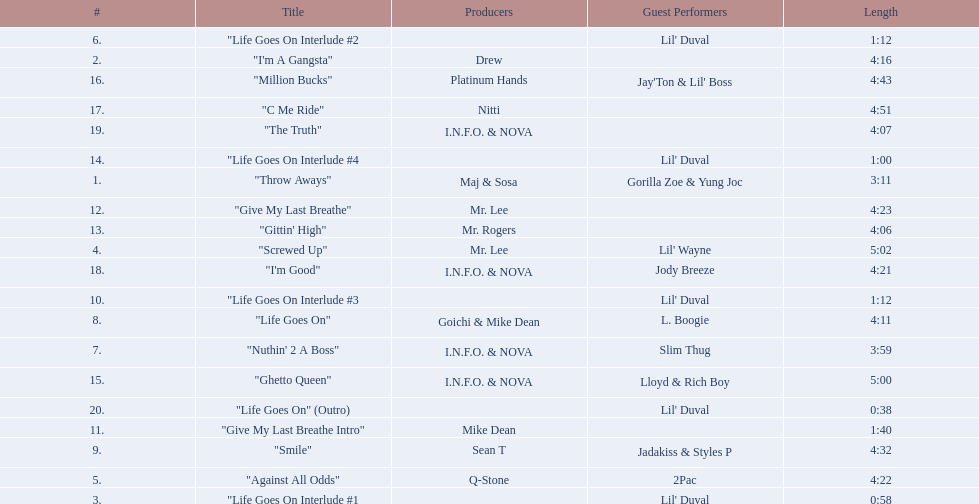How long is track number 11? 1:40. Can you parse all the data within this table? {'header': ['#', 'Title', 'Producers', 'Guest Performers', 'Length'], 'rows': [['6.', '"Life Goes On Interlude #2', '', "Lil' Duval", '1:12'], ['2.', '"I\'m A Gangsta"', 'Drew', '', '4:16'], ['16.', '"Million Bucks"', 'Platinum Hands', "Jay'Ton & Lil' Boss", '4:43'], ['17.', '"C Me Ride"', 'Nitti', '', '4:51'], ['19.', '"The Truth"', 'I.N.F.O. & NOVA', '', '4:07'], ['14.', '"Life Goes On Interlude #4', '', "Lil' Duval", '1:00'], ['1.', '"Throw Aways"', 'Maj & Sosa', 'Gorilla Zoe & Yung Joc', '3:11'], ['12.', '"Give My Last Breathe"', 'Mr. Lee', '', '4:23'], ['13.', '"Gittin\' High"', 'Mr. Rogers', '', '4:06'], ['4.', '"Screwed Up"', 'Mr. Lee', "Lil' Wayne", '5:02'], ['18.', '"I\'m Good"', 'I.N.F.O. & NOVA', 'Jody Breeze', '4:21'], ['10.', '"Life Goes On Interlude #3', '', "Lil' Duval", '1:12'], ['8.', '"Life Goes On"', 'Goichi & Mike Dean', 'L. Boogie', '4:11'], ['7.', '"Nuthin\' 2 A Boss"', 'I.N.F.O. & NOVA', 'Slim Thug', '3:59'], ['15.', '"Ghetto Queen"', 'I.N.F.O. & NOVA', 'Lloyd & Rich Boy', '5:00'], ['20.', '"Life Goes On" (Outro)', '', "Lil' Duval", '0:38'], ['11.', '"Give My Last Breathe Intro"', 'Mike Dean', '', '1:40'], ['9.', '"Smile"', 'Sean T', 'Jadakiss & Styles P', '4:32'], ['5.', '"Against All Odds"', 'Q-Stone', '2Pac', '4:22'], ['3.', '"Life Goes On Interlude #1', '', "Lil' Duval", '0:58']]} 